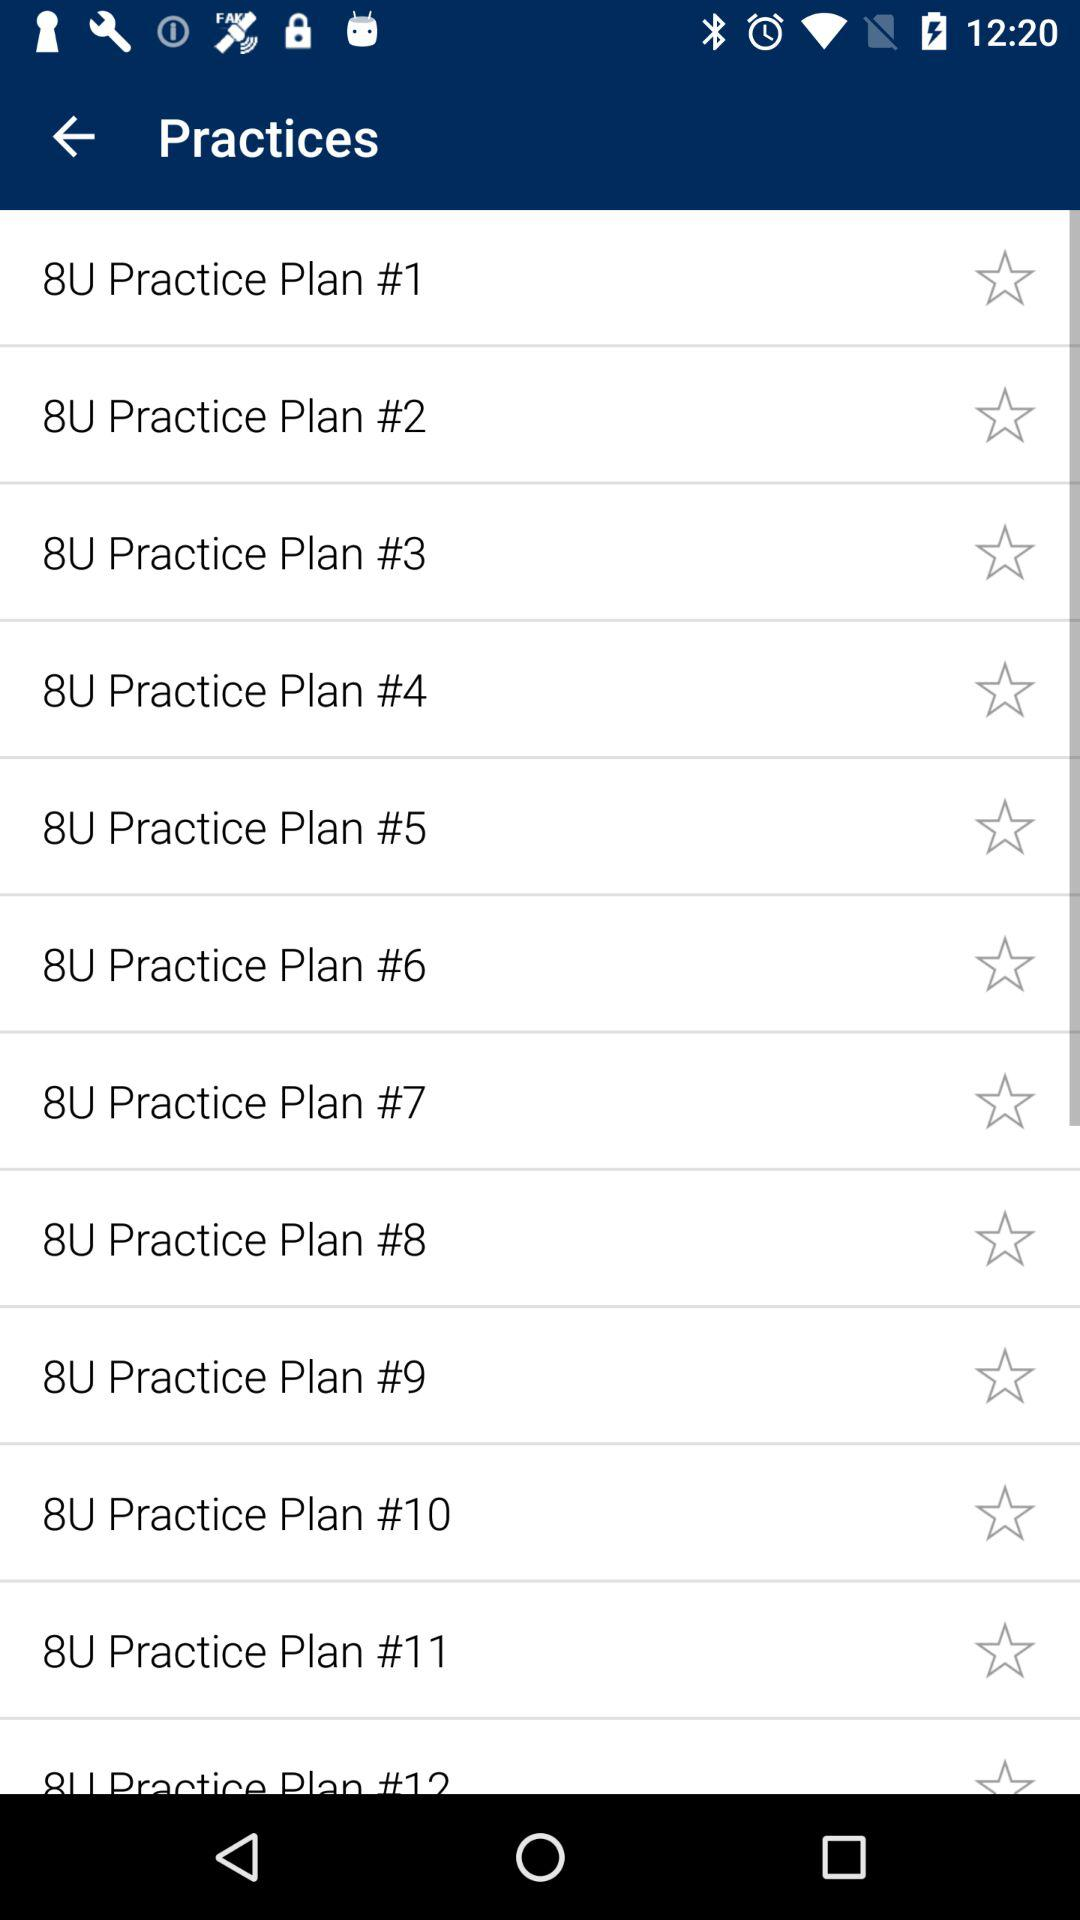How many practice plans are there?
Answer the question using a single word or phrase. 12 